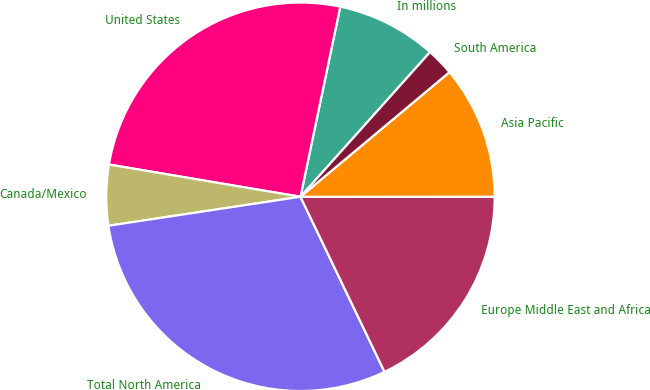Convert chart. <chart><loc_0><loc_0><loc_500><loc_500><pie_chart><fcel>In millions<fcel>United States<fcel>Canada/Mexico<fcel>Total North America<fcel>Europe Middle East and Africa<fcel>Asia Pacific<fcel>South America<nl><fcel>8.34%<fcel>25.63%<fcel>5.04%<fcel>29.74%<fcel>17.88%<fcel>11.08%<fcel>2.29%<nl></chart> 